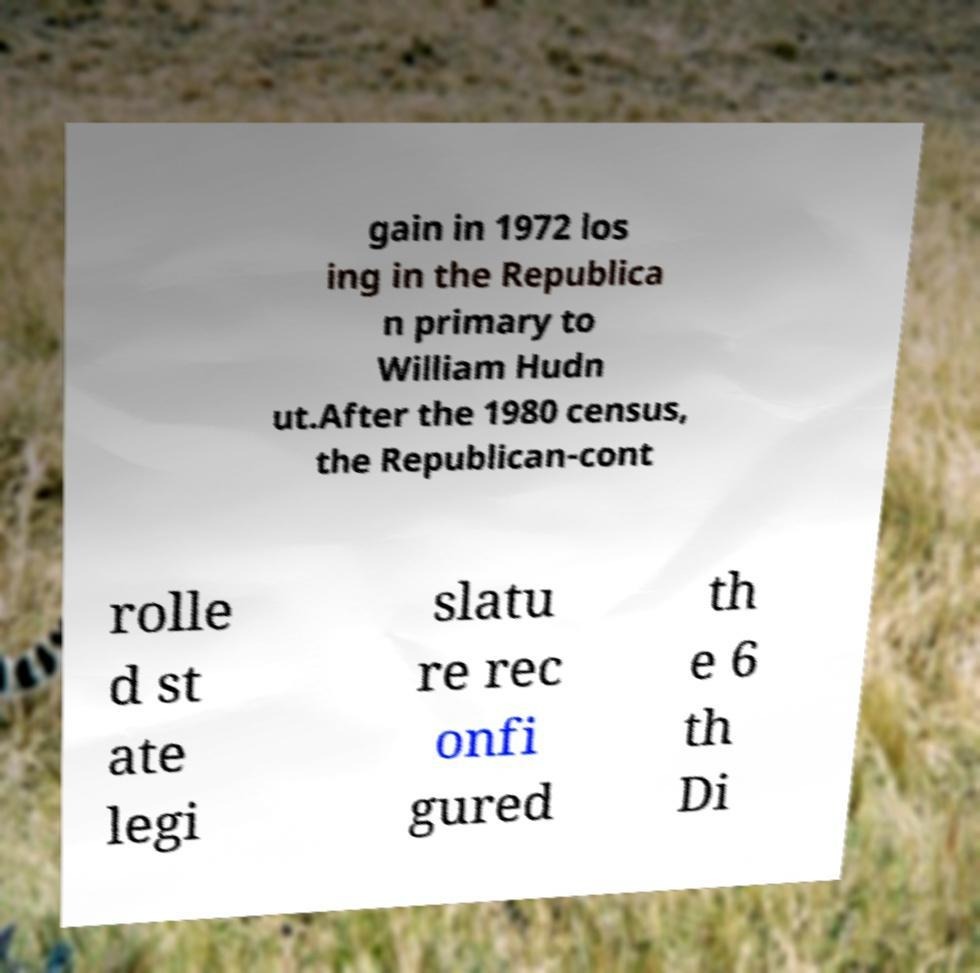For documentation purposes, I need the text within this image transcribed. Could you provide that? gain in 1972 los ing in the Republica n primary to William Hudn ut.After the 1980 census, the Republican-cont rolle d st ate legi slatu re rec onfi gured th e 6 th Di 